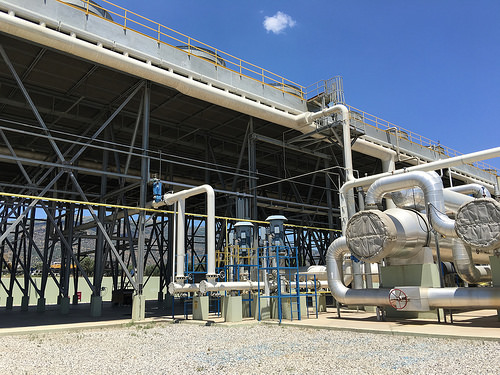<image>
Can you confirm if the pillar is to the left of the tank? Yes. From this viewpoint, the pillar is positioned to the left side relative to the tank. 